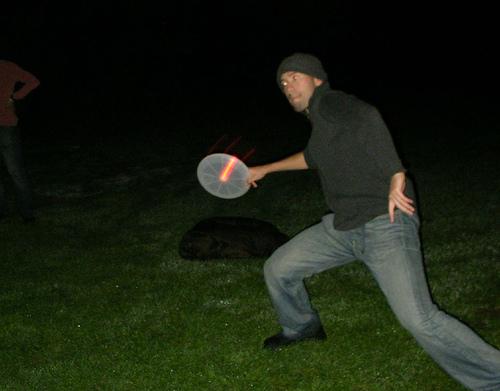Is it daytime?
Concise answer only. No. What type of shoes is he wearing?
Quick response, please. Tennis. What is the man riding on?
Answer briefly. Nothing. What kind of hat is the boy wearing?
Be succinct. Beanie. Is there are car in this picture?
Short answer required. No. Is this person an adult?
Answer briefly. Yes. Does this man look like he get much exercise?
Quick response, please. Yes. How many men do you see?
Keep it brief. 1. Is this man holding a white frisbee?
Quick response, please. Yes. What would this by like to hit?
Be succinct. Hard. Is it sunny in this picture?
Write a very short answer. No. What sport is this?
Quick response, please. Frisbee. How many frisbees are there?
Write a very short answer. 1. What is the dog doing?
Be succinct. Sleeping. What is the guy in the photo  playing?
Quick response, please. Frisbee. How many people are wearing hats?
Short answer required. 1. Is this taking place at night?
Short answer required. Yes. What is in his left hand?
Concise answer only. Frisbee. 